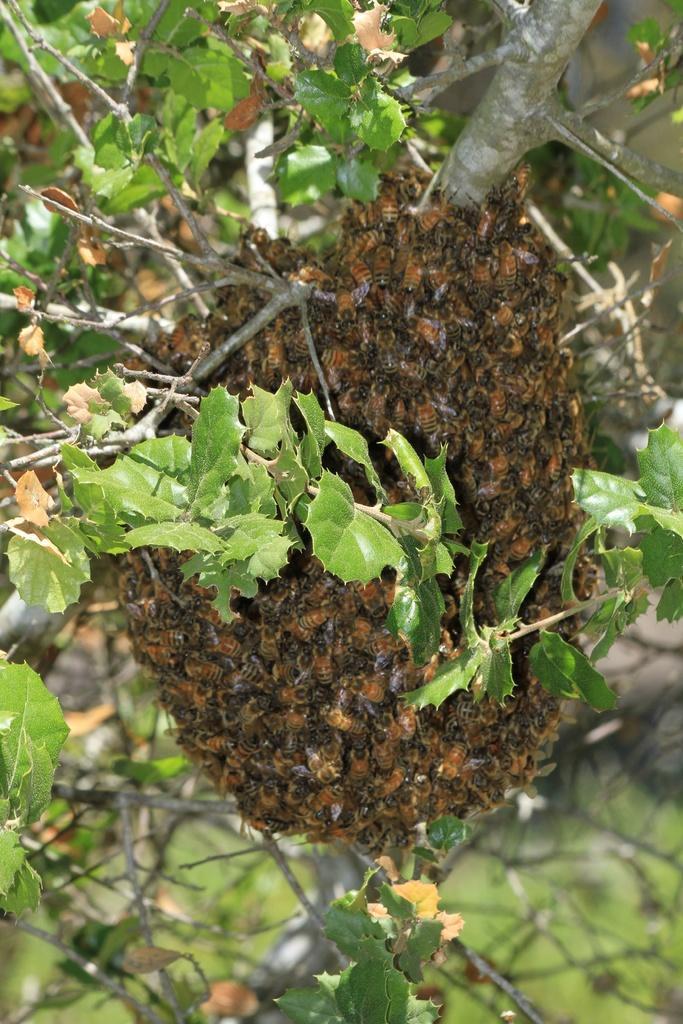Please provide a concise description of this image. In the image there is a bees swarm to a tree. 